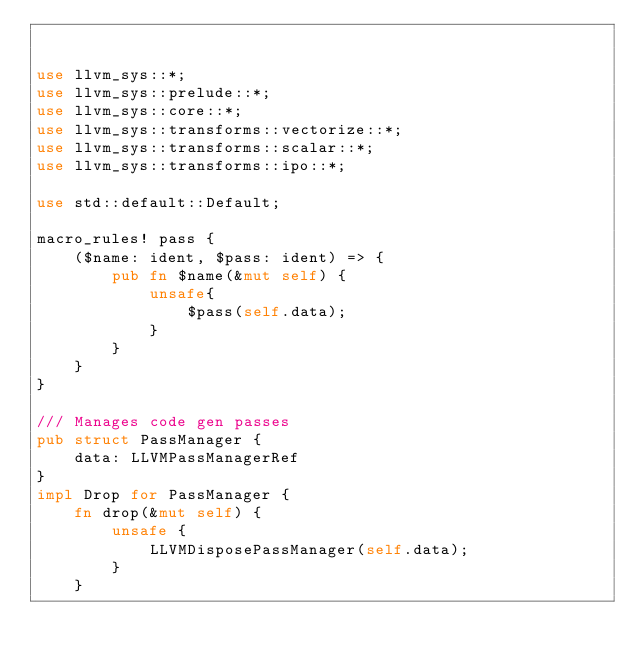Convert code to text. <code><loc_0><loc_0><loc_500><loc_500><_Rust_>

use llvm_sys::*;
use llvm_sys::prelude::*;
use llvm_sys::core::*;
use llvm_sys::transforms::vectorize::*;
use llvm_sys::transforms::scalar::*;
use llvm_sys::transforms::ipo::*;

use std::default::Default;

macro_rules! pass {
    ($name: ident, $pass: ident) => {
        pub fn $name(&mut self) {
            unsafe{
                $pass(self.data);
            }
        }
    }
}

/// Manages code gen passes
pub struct PassManager {
    data: LLVMPassManagerRef
}
impl Drop for PassManager {
    fn drop(&mut self) {
        unsafe {
            LLVMDisposePassManager(self.data);
        }
    }</code> 